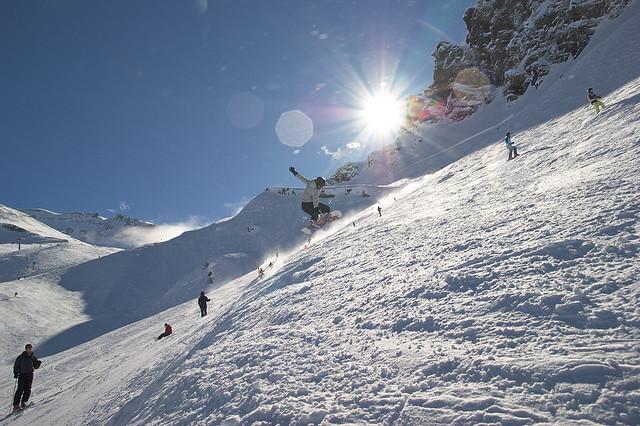What season is this?
Be succinct. Winter. Is it cloudy?
Answer briefly. No. What kind of day is it?
Answer briefly. Sunny. Where is this shot from?
Concise answer only. Downhill. What color is the snow?
Concise answer only. White. What trick is the snowboarder doing?
Give a very brief answer. Jump. 